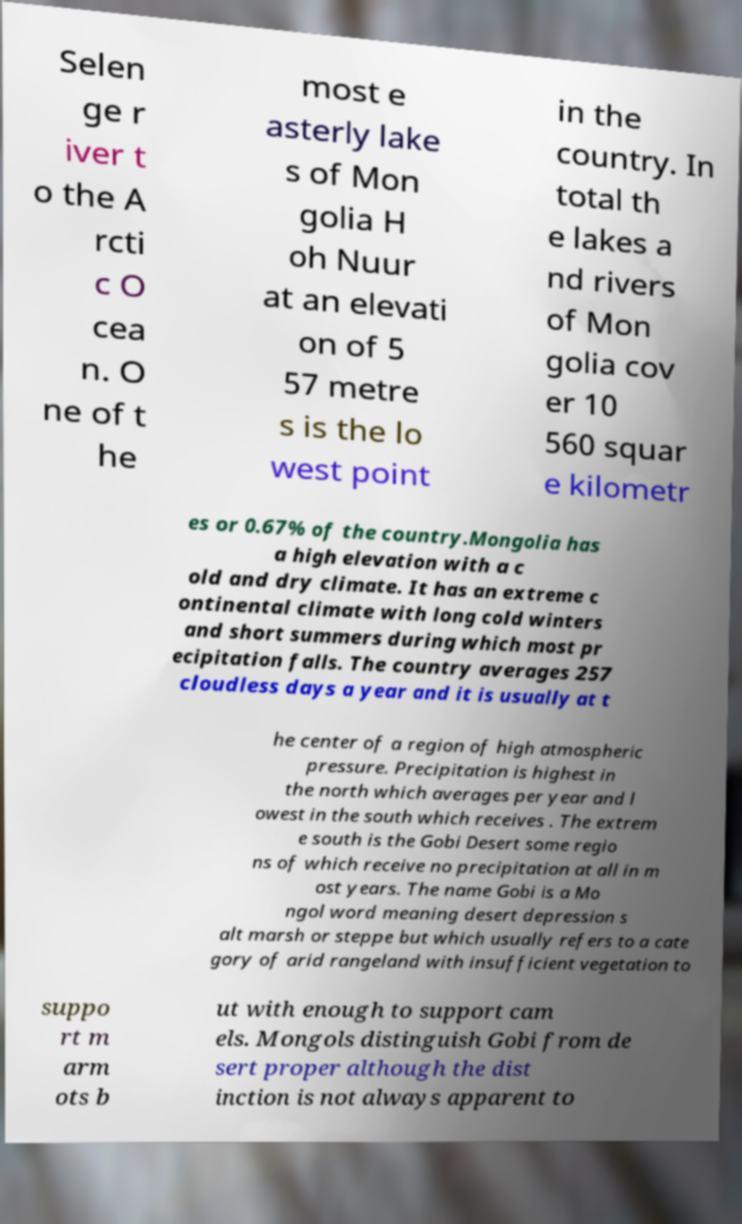For documentation purposes, I need the text within this image transcribed. Could you provide that? Selen ge r iver t o the A rcti c O cea n. O ne of t he most e asterly lake s of Mon golia H oh Nuur at an elevati on of 5 57 metre s is the lo west point in the country. In total th e lakes a nd rivers of Mon golia cov er 10 560 squar e kilometr es or 0.67% of the country.Mongolia has a high elevation with a c old and dry climate. It has an extreme c ontinental climate with long cold winters and short summers during which most pr ecipitation falls. The country averages 257 cloudless days a year and it is usually at t he center of a region of high atmospheric pressure. Precipitation is highest in the north which averages per year and l owest in the south which receives . The extrem e south is the Gobi Desert some regio ns of which receive no precipitation at all in m ost years. The name Gobi is a Mo ngol word meaning desert depression s alt marsh or steppe but which usually refers to a cate gory of arid rangeland with insufficient vegetation to suppo rt m arm ots b ut with enough to support cam els. Mongols distinguish Gobi from de sert proper although the dist inction is not always apparent to 